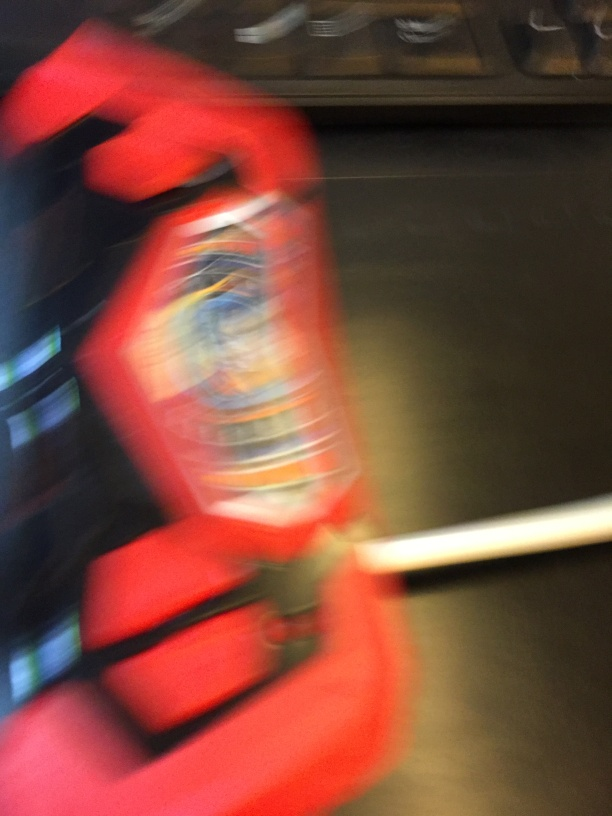Is the background blurry and lacking clarity?
A. No
B. Yes
Answer with the option's letter from the given choices directly.
 B. 